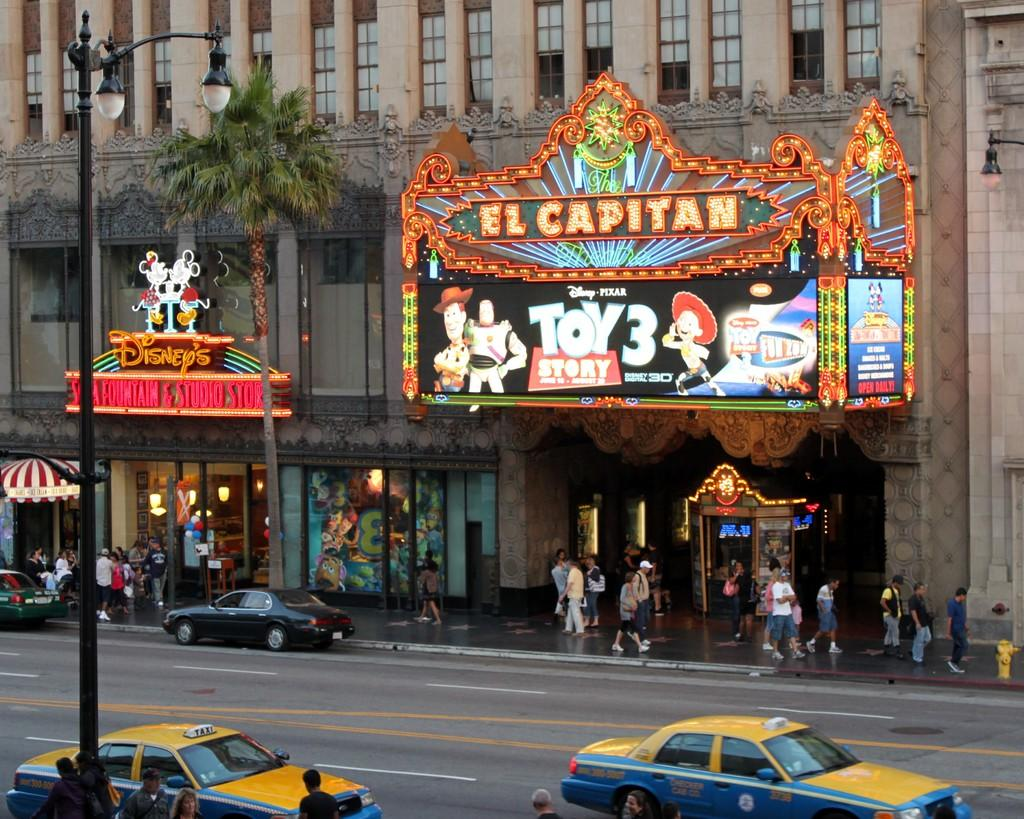<image>
Share a concise interpretation of the image provided. The outside of a theater with the words El Capitan written on it showing a banner for the movie Toy Story 3. 